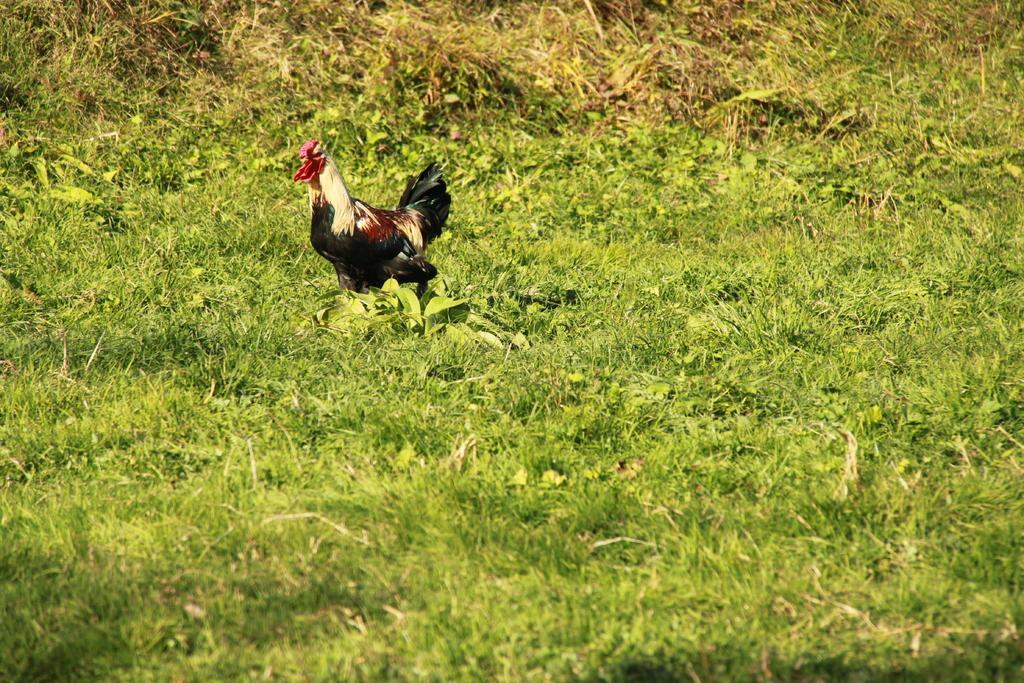Could you give a brief overview of what you see in this image? In this image there is a cock on a grassland. 